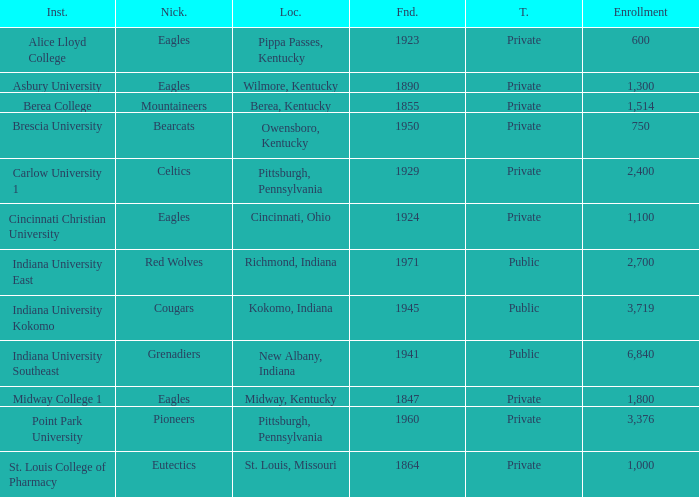Which of the private colleges is the oldest, and whose nickname is the Mountaineers? 1855.0. 